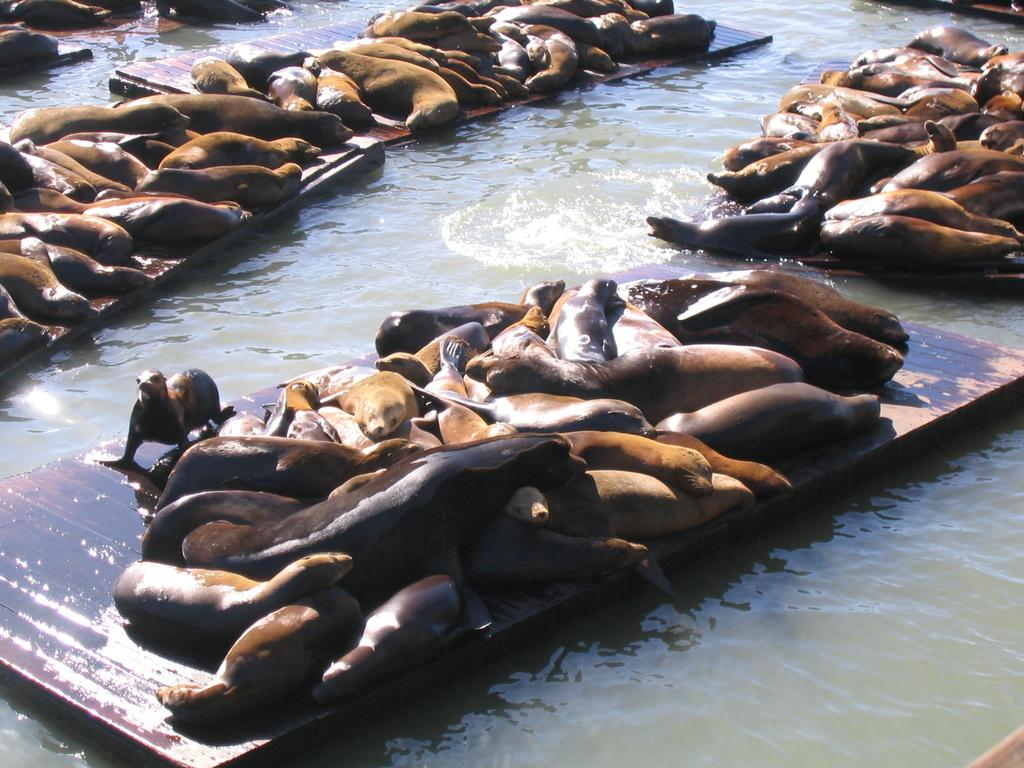What is the primary element visible in the image? There is water in the image. What type of animals can be seen in the image? There are seals in the image. How are the seals positioned in the image? The seals are on wooden sticks. What type of fork can be seen in the image? There is no fork present in the image; it features water and seals on wooden sticks. 